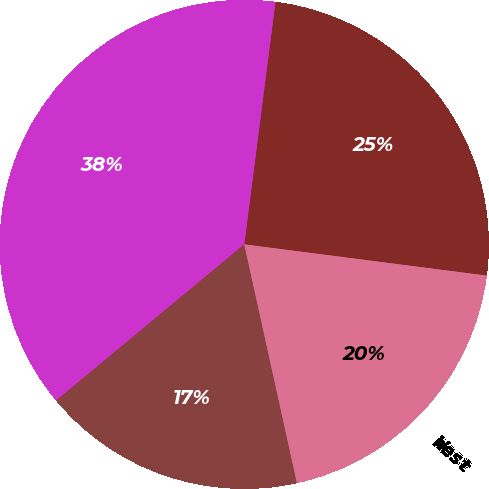Convert chart to OTSL. <chart><loc_0><loc_0><loc_500><loc_500><pie_chart><fcel>East<fcel>Gulf Coast<fcel>Central<fcel>West<nl><fcel>25.0%<fcel>38.06%<fcel>17.43%<fcel>19.5%<nl></chart> 